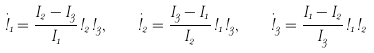<formula> <loc_0><loc_0><loc_500><loc_500>\dot { \omega } _ { 1 } = \frac { I _ { 2 } - I _ { 3 } } { I _ { 1 } } \omega _ { 2 } \omega _ { 3 } , \quad \dot { \omega } _ { 2 } = \frac { I _ { 3 } - I _ { 1 } } { I _ { 2 } } \omega _ { 1 } \omega _ { 3 } , \quad \dot { \omega } _ { 3 } = \frac { I _ { 1 } - I _ { 2 } } { I _ { 3 } } \omega _ { 1 } \omega _ { 2 }</formula> 